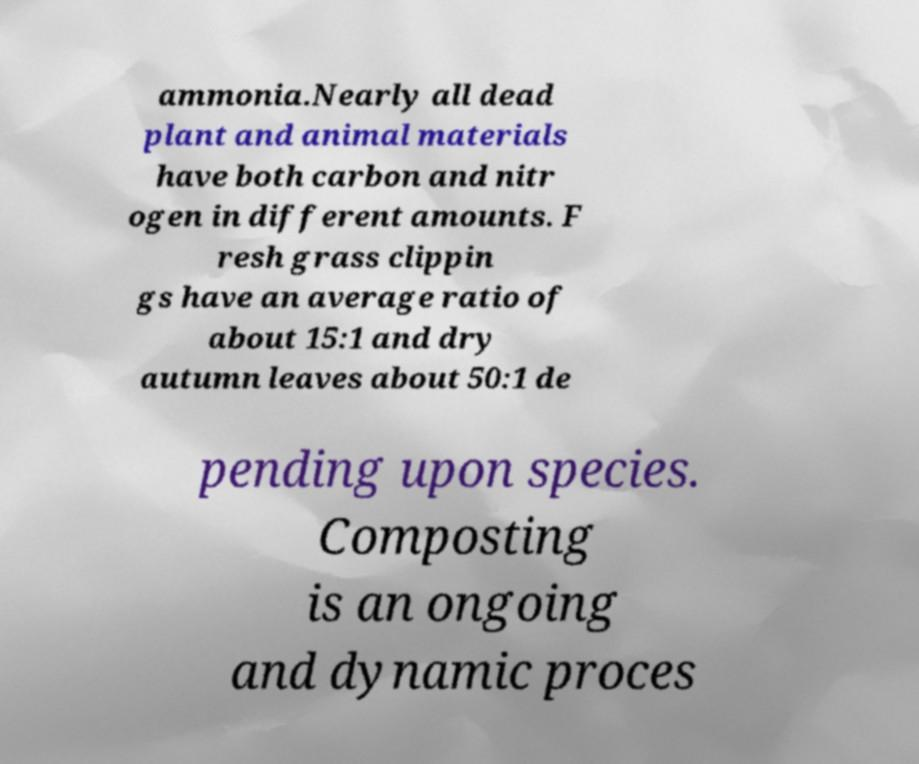Can you accurately transcribe the text from the provided image for me? ammonia.Nearly all dead plant and animal materials have both carbon and nitr ogen in different amounts. F resh grass clippin gs have an average ratio of about 15:1 and dry autumn leaves about 50:1 de pending upon species. Composting is an ongoing and dynamic proces 